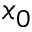Convert formula to latex. <formula><loc_0><loc_0><loc_500><loc_500>x _ { 0 }</formula> 